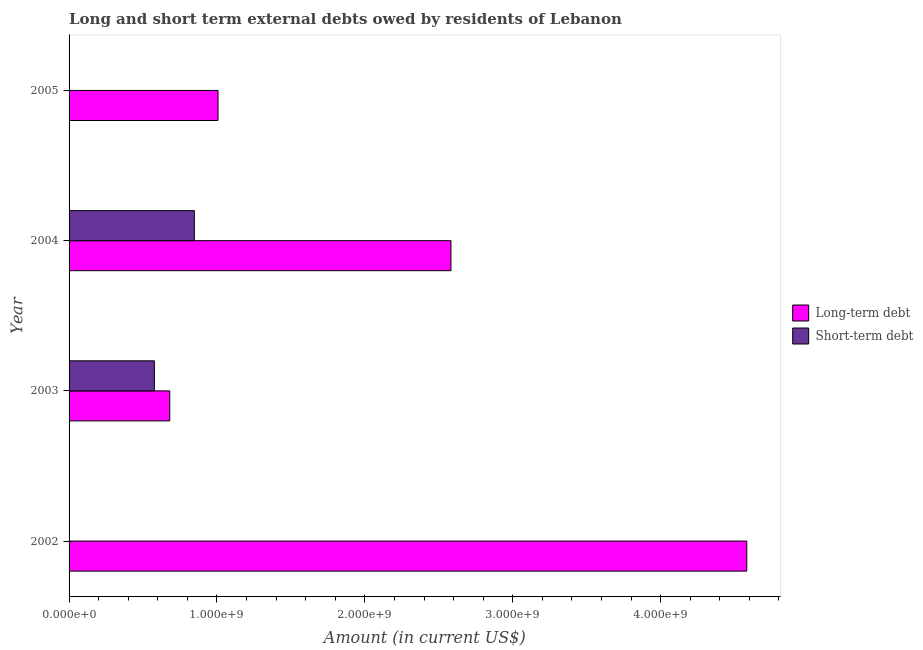Are the number of bars on each tick of the Y-axis equal?
Make the answer very short. No. In how many cases, is the number of bars for a given year not equal to the number of legend labels?
Offer a very short reply. 2. What is the short-term debts owed by residents in 2004?
Make the answer very short. 8.47e+08. Across all years, what is the maximum long-term debts owed by residents?
Offer a terse response. 4.58e+09. Across all years, what is the minimum short-term debts owed by residents?
Give a very brief answer. 0. In which year was the long-term debts owed by residents maximum?
Give a very brief answer. 2002. What is the total short-term debts owed by residents in the graph?
Offer a very short reply. 1.42e+09. What is the difference between the short-term debts owed by residents in 2003 and that in 2004?
Your answer should be compact. -2.70e+08. What is the difference between the short-term debts owed by residents in 2004 and the long-term debts owed by residents in 2003?
Ensure brevity in your answer.  1.66e+08. What is the average short-term debts owed by residents per year?
Give a very brief answer. 3.56e+08. In the year 2003, what is the difference between the long-term debts owed by residents and short-term debts owed by residents?
Provide a short and direct response. 1.04e+08. What is the ratio of the long-term debts owed by residents in 2002 to that in 2005?
Your answer should be very brief. 4.55. Is the short-term debts owed by residents in 2003 less than that in 2004?
Offer a terse response. Yes. What is the difference between the highest and the second highest long-term debts owed by residents?
Offer a terse response. 2.00e+09. What is the difference between the highest and the lowest short-term debts owed by residents?
Give a very brief answer. 8.47e+08. Are all the bars in the graph horizontal?
Offer a terse response. Yes. What is the difference between two consecutive major ticks on the X-axis?
Your answer should be compact. 1.00e+09. Are the values on the major ticks of X-axis written in scientific E-notation?
Ensure brevity in your answer.  Yes. Does the graph contain any zero values?
Provide a succinct answer. Yes. Where does the legend appear in the graph?
Give a very brief answer. Center right. How many legend labels are there?
Your response must be concise. 2. What is the title of the graph?
Provide a short and direct response. Long and short term external debts owed by residents of Lebanon. What is the label or title of the Y-axis?
Make the answer very short. Year. What is the Amount (in current US$) in Long-term debt in 2002?
Ensure brevity in your answer.  4.58e+09. What is the Amount (in current US$) of Short-term debt in 2002?
Ensure brevity in your answer.  0. What is the Amount (in current US$) of Long-term debt in 2003?
Make the answer very short. 6.81e+08. What is the Amount (in current US$) in Short-term debt in 2003?
Your answer should be very brief. 5.77e+08. What is the Amount (in current US$) of Long-term debt in 2004?
Your answer should be compact. 2.58e+09. What is the Amount (in current US$) in Short-term debt in 2004?
Make the answer very short. 8.47e+08. What is the Amount (in current US$) of Long-term debt in 2005?
Offer a terse response. 1.01e+09. Across all years, what is the maximum Amount (in current US$) of Long-term debt?
Provide a succinct answer. 4.58e+09. Across all years, what is the maximum Amount (in current US$) of Short-term debt?
Your response must be concise. 8.47e+08. Across all years, what is the minimum Amount (in current US$) in Long-term debt?
Offer a very short reply. 6.81e+08. What is the total Amount (in current US$) of Long-term debt in the graph?
Offer a terse response. 8.85e+09. What is the total Amount (in current US$) in Short-term debt in the graph?
Your answer should be very brief. 1.42e+09. What is the difference between the Amount (in current US$) in Long-term debt in 2002 and that in 2003?
Make the answer very short. 3.90e+09. What is the difference between the Amount (in current US$) in Long-term debt in 2002 and that in 2004?
Offer a very short reply. 2.00e+09. What is the difference between the Amount (in current US$) in Long-term debt in 2002 and that in 2005?
Your answer should be very brief. 3.58e+09. What is the difference between the Amount (in current US$) in Long-term debt in 2003 and that in 2004?
Your answer should be compact. -1.90e+09. What is the difference between the Amount (in current US$) in Short-term debt in 2003 and that in 2004?
Offer a terse response. -2.70e+08. What is the difference between the Amount (in current US$) in Long-term debt in 2003 and that in 2005?
Make the answer very short. -3.26e+08. What is the difference between the Amount (in current US$) in Long-term debt in 2004 and that in 2005?
Offer a terse response. 1.57e+09. What is the difference between the Amount (in current US$) in Long-term debt in 2002 and the Amount (in current US$) in Short-term debt in 2003?
Provide a short and direct response. 4.01e+09. What is the difference between the Amount (in current US$) in Long-term debt in 2002 and the Amount (in current US$) in Short-term debt in 2004?
Your answer should be compact. 3.74e+09. What is the difference between the Amount (in current US$) of Long-term debt in 2003 and the Amount (in current US$) of Short-term debt in 2004?
Ensure brevity in your answer.  -1.66e+08. What is the average Amount (in current US$) of Long-term debt per year?
Ensure brevity in your answer.  2.21e+09. What is the average Amount (in current US$) of Short-term debt per year?
Your answer should be very brief. 3.56e+08. In the year 2003, what is the difference between the Amount (in current US$) of Long-term debt and Amount (in current US$) of Short-term debt?
Give a very brief answer. 1.04e+08. In the year 2004, what is the difference between the Amount (in current US$) of Long-term debt and Amount (in current US$) of Short-term debt?
Make the answer very short. 1.74e+09. What is the ratio of the Amount (in current US$) of Long-term debt in 2002 to that in 2003?
Ensure brevity in your answer.  6.73. What is the ratio of the Amount (in current US$) in Long-term debt in 2002 to that in 2004?
Your response must be concise. 1.77. What is the ratio of the Amount (in current US$) of Long-term debt in 2002 to that in 2005?
Give a very brief answer. 4.55. What is the ratio of the Amount (in current US$) of Long-term debt in 2003 to that in 2004?
Make the answer very short. 0.26. What is the ratio of the Amount (in current US$) in Short-term debt in 2003 to that in 2004?
Keep it short and to the point. 0.68. What is the ratio of the Amount (in current US$) of Long-term debt in 2003 to that in 2005?
Your answer should be compact. 0.68. What is the ratio of the Amount (in current US$) in Long-term debt in 2004 to that in 2005?
Your answer should be compact. 2.56. What is the difference between the highest and the second highest Amount (in current US$) in Long-term debt?
Provide a succinct answer. 2.00e+09. What is the difference between the highest and the lowest Amount (in current US$) in Long-term debt?
Your response must be concise. 3.90e+09. What is the difference between the highest and the lowest Amount (in current US$) of Short-term debt?
Provide a succinct answer. 8.47e+08. 